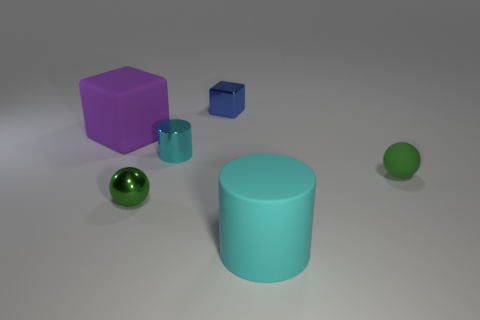Add 3 tiny cyan objects. How many objects exist? 9 Subtract all cubes. How many objects are left? 4 Subtract all small shiny objects. Subtract all tiny cylinders. How many objects are left? 2 Add 3 shiny cylinders. How many shiny cylinders are left? 4 Add 3 tiny green rubber objects. How many tiny green rubber objects exist? 4 Subtract 0 brown balls. How many objects are left? 6 